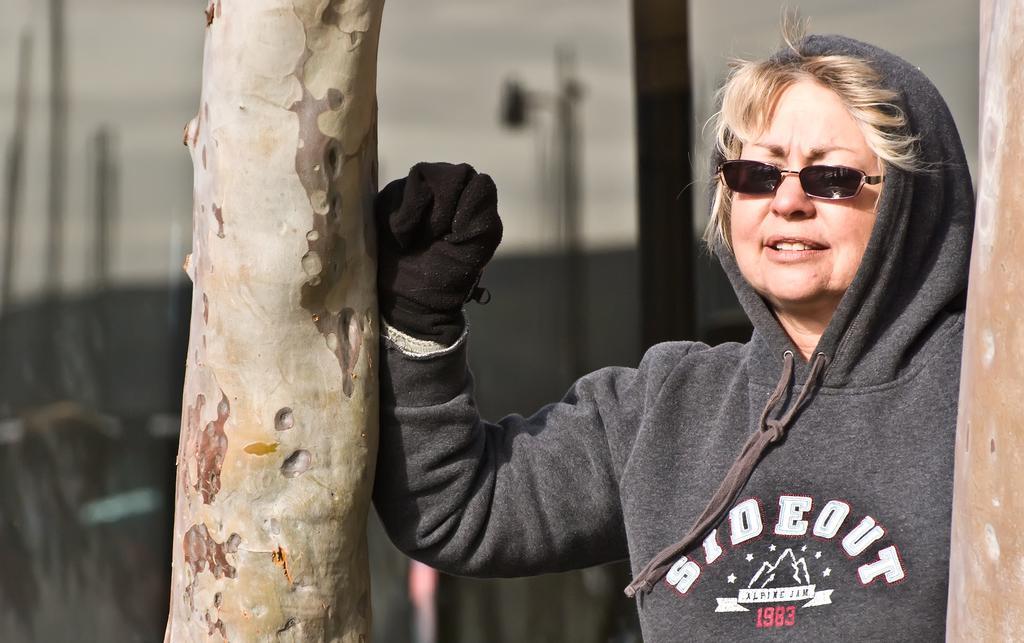How would you summarize this image in a sentence or two? In this picture we can see a woman wearing spectacle, jacket and a glove in her hand. She is standing and kept her hand on a tree trunk. We can see a wooden object on the right side. There are a few objects visible in the background. Background is blurry. 